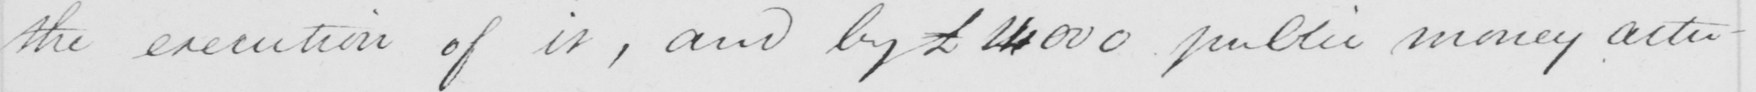Please provide the text content of this handwritten line. the execution of it , and by £24.000 public money actu- 